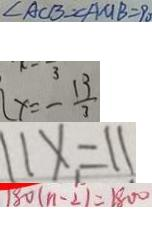Convert formula to latex. <formula><loc_0><loc_0><loc_500><loc_500>\angle A C B = \angle A M B = 9 0 
 x = - \frac { 1 3 } { 3 } 
 1 1 x = 1 1 
 1 8 0 ( n - 2 ) = 1 8 0 0</formula> 